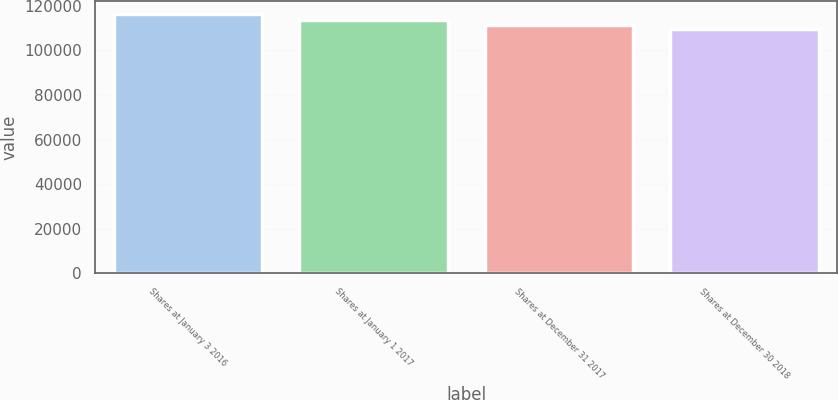<chart> <loc_0><loc_0><loc_500><loc_500><bar_chart><fcel>Shares at January 3 2016<fcel>Shares at January 1 2017<fcel>Shares at December 31 2017<fcel>Shares at December 30 2018<nl><fcel>116517<fcel>113455<fcel>111306<fcel>109652<nl></chart> 